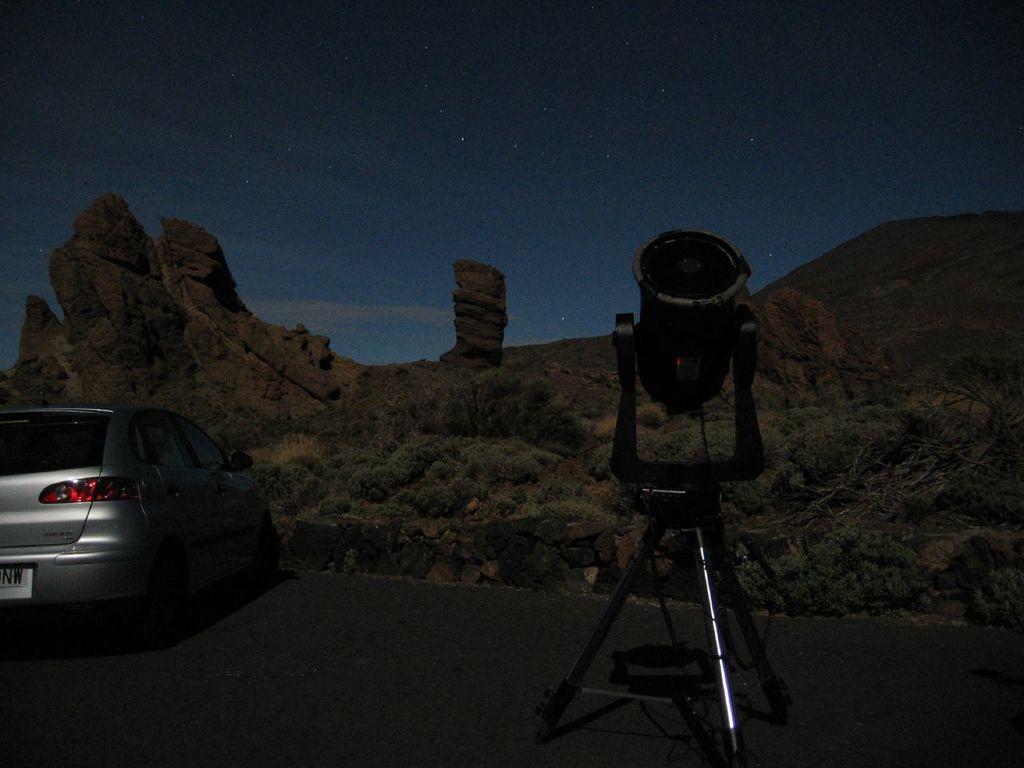In one or two sentences, can you explain what this image depicts? In this image I can see a standing which is made up of metal and a light on it, a car which is silver in color on the road, few trees and a mountain. In the background I can see the sky and few stars in the sky. 